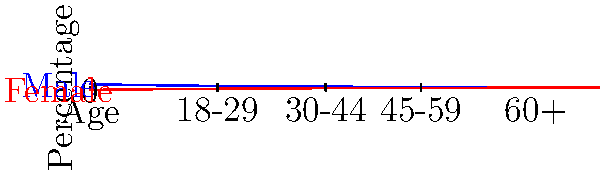The population pyramid above shows the demographic breakdown of SPD voters by age groups. Based on this graph, which age group appears to have the highest percentage of SPD voters for both males and females? To determine which age group has the highest percentage of SPD voters for both males and females, we need to analyze the graph step-by-step:

1. The graph shows four age groups: 18-29, 30-44, 45-59, and 60+.
2. The blue line represents male voters, while the red line represents female voters.
3. The y-axis represents the percentage of voters, with positive values for males and negative values for females.
4. The x-axis represents age, increasing from left to right.
5. To find the highest percentage, we need to look at the peak of both curves.

For males (blue line):
- The curve peaks around the 45-59 age group.

For females (red line):
- The curve also peaks around the 45-59 age group.

Both curves show the highest absolute values (ignoring the negative sign for females) in the 45-59 age range, indicating that this age group has the highest percentage of SPD voters for both genders.
Answer: 45-59 age group 